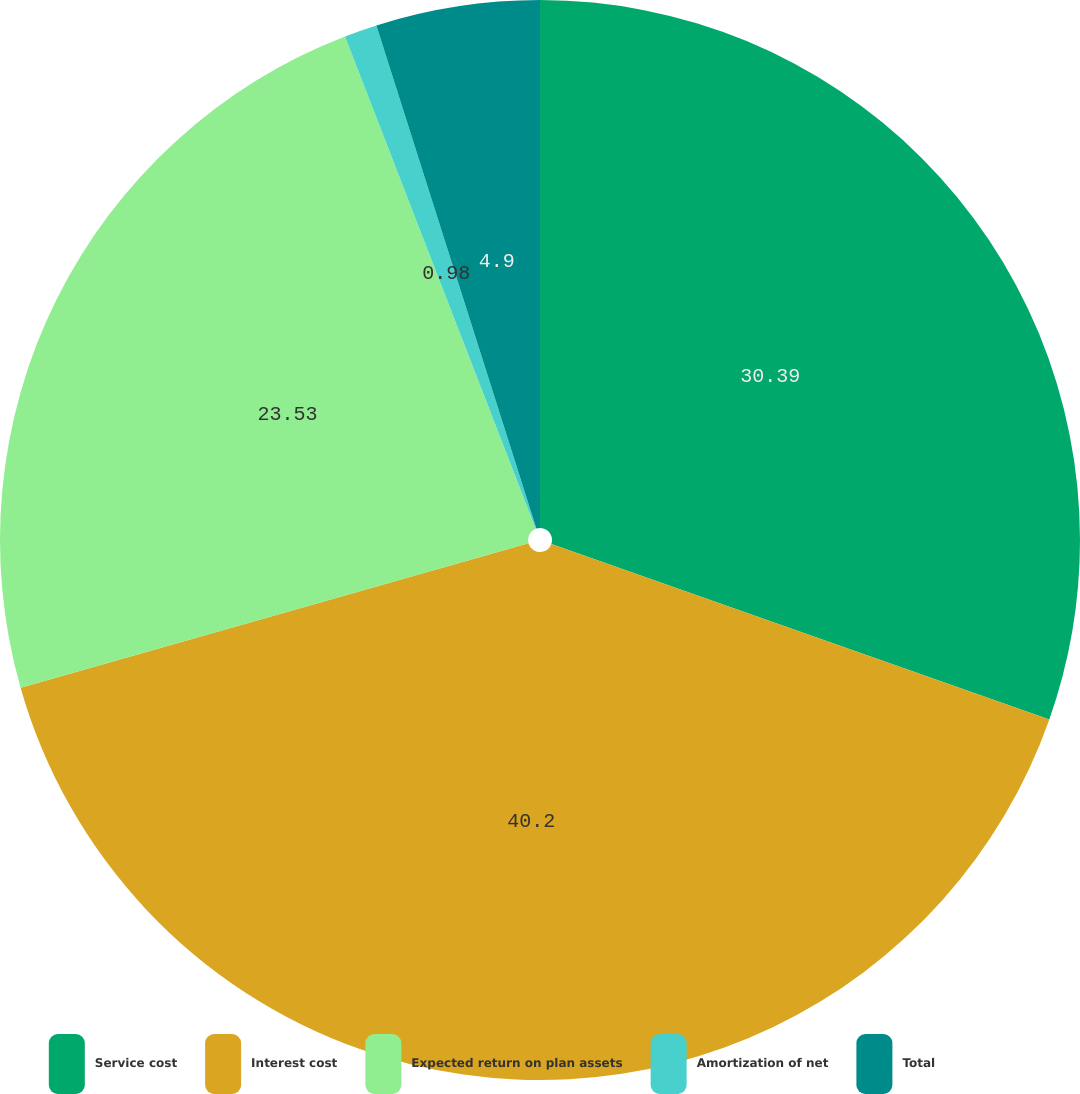Convert chart. <chart><loc_0><loc_0><loc_500><loc_500><pie_chart><fcel>Service cost<fcel>Interest cost<fcel>Expected return on plan assets<fcel>Amortization of net<fcel>Total<nl><fcel>30.39%<fcel>40.2%<fcel>23.53%<fcel>0.98%<fcel>4.9%<nl></chart> 